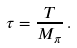<formula> <loc_0><loc_0><loc_500><loc_500>\tau = \frac { T } { M _ { \pi } } \, .</formula> 